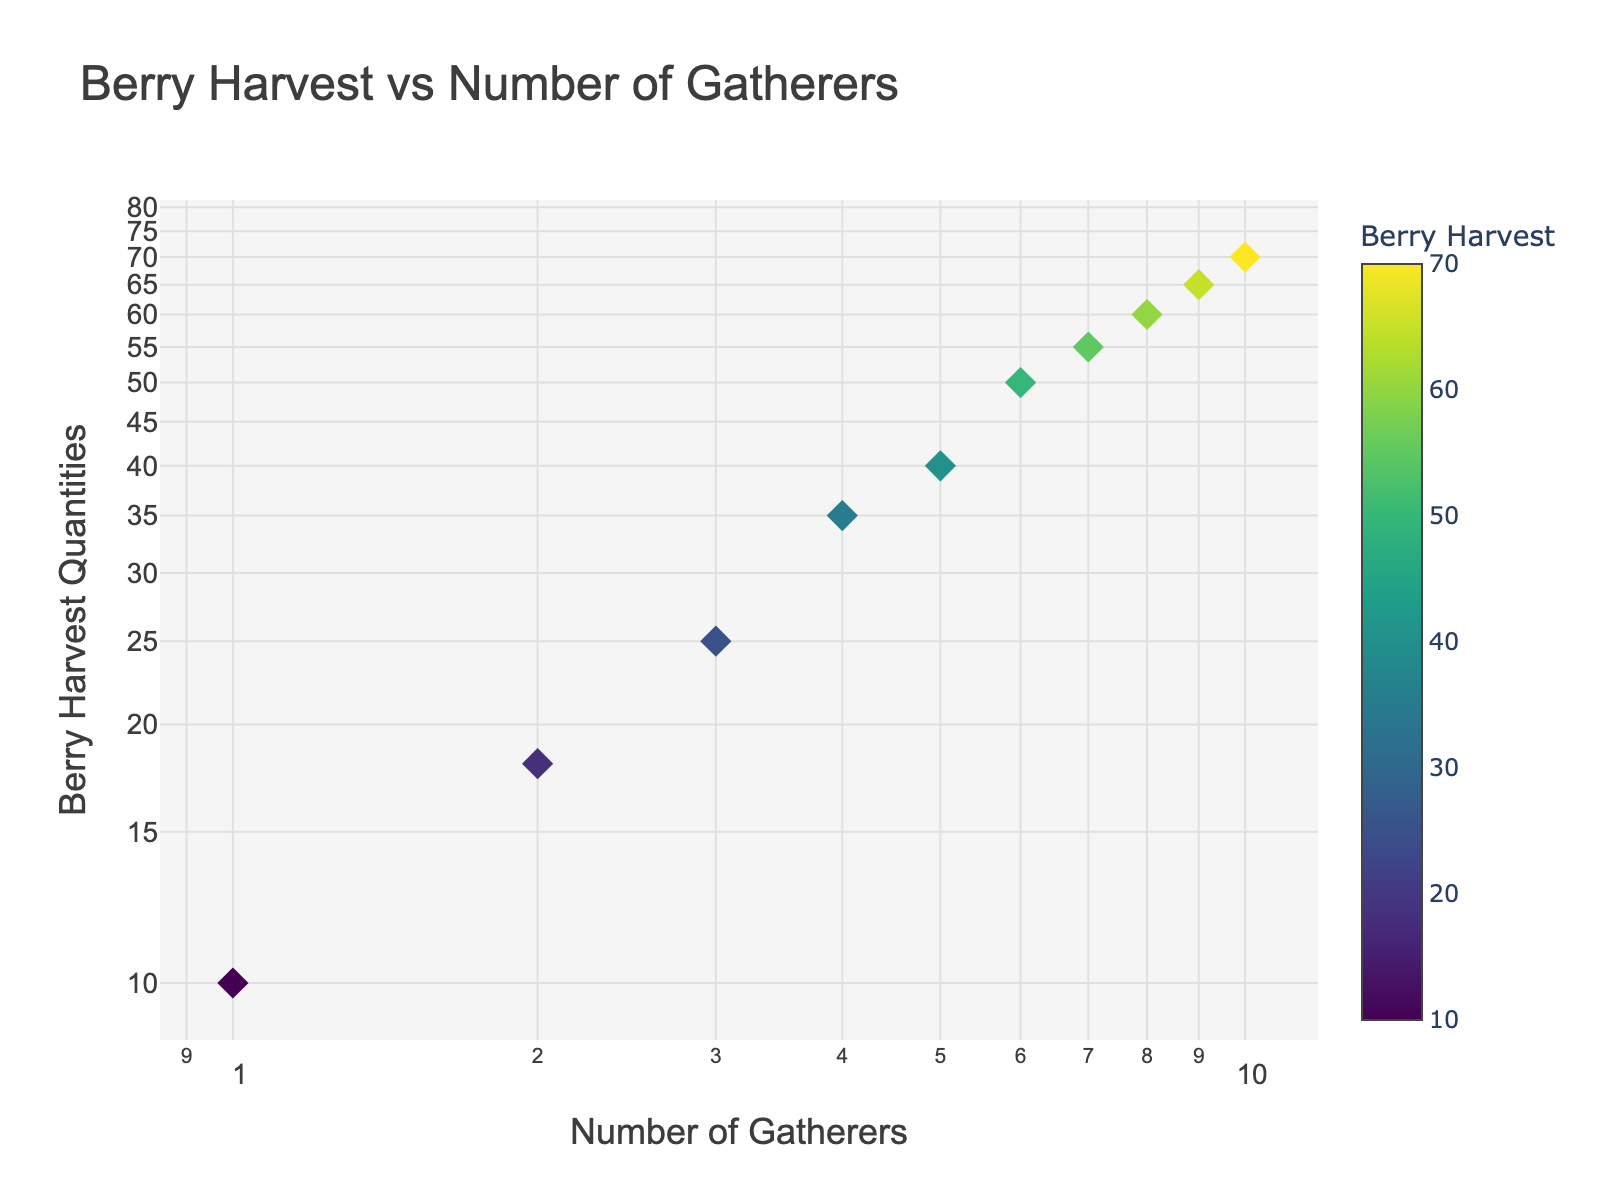How many data points are there in the figure? The figure shows ten data points corresponding to the number of gatherers from 1 to 10.
Answer: 10 What is the title of the figure? The title text is positioned at the top of the figure, indicating the relationship it is illustrating.
Answer: Berry Harvest vs Number of Gatherers What is the color of the data points that represent the highest and lowest berry harvest quantities? The color scale ranges from dark (low values) to light (high values). The point with the lowest value (10) will be darkest, and the highest value (70) will be lightest.
Answer: Dark for lowest, light for highest Which axis represents the number of gatherers, and which represents berry harvest quantities? Based on the axis titles, the x-axis represents the 'Number of Gatherers', and the y-axis represents 'Berry Harvest Quantities'.
Answer: x-axis: Number of Gatherers, y-axis: Berry Harvest Quantities At what number of gatherers does the berry harvest quantity cross 50? Looking at the y-axis, find the point where the y-value (Berry Harvest Quantities) exceeds 50 and note the corresponding x-value (Number of Gatherers).
Answer: 6 What is the berry harvest quantity when there are 4 gatherers? Identify the data point corresponding to 4 gatherers on the x-axis and read its value on the y-axis.
Answer: 35 Which gatherer number sees the largest increase in berry harvest quantity from the previous gatherer? Compare the differences between consecutive berry harvest quantities and find the largest increase. From the 3rd gatherer to the 4th gatherer, the increase (35 - 25 = 10) is the largest.
Answer: 4th What trend can be seen in the scatter plot as the number of gatherers increases from 1 to 10? The scatter plot shows an increasing trend in berry harvest quantities as the number of gatherers increases, though the rate of increase slows down after a certain point. This can be inferred by observing the upward pattern of the data points.
Answer: Increasing trend How does the log scale affect the visualization of the relationship between the number of gatherers and berry harvest quantities? Log scales compress the wide range of values, making it easier to observe proportional relationships and small differences at lower values. This adjustment helps in highlighting trends in non-linear data.
Answer: Compresses value range, highlights trends 